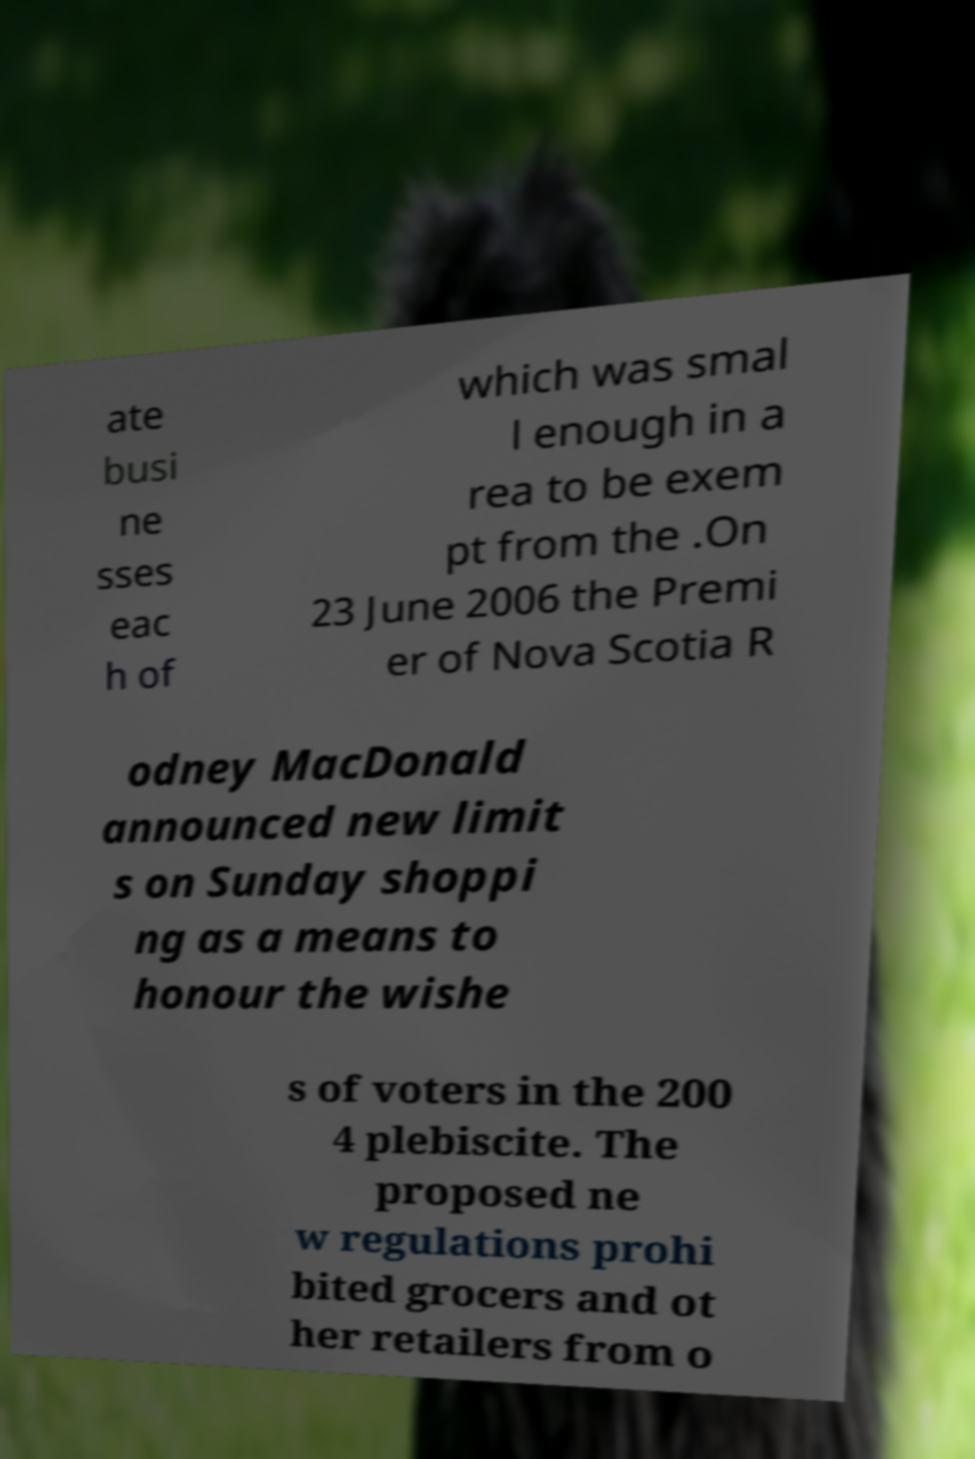Can you read and provide the text displayed in the image?This photo seems to have some interesting text. Can you extract and type it out for me? ate busi ne sses eac h of which was smal l enough in a rea to be exem pt from the .On 23 June 2006 the Premi er of Nova Scotia R odney MacDonald announced new limit s on Sunday shoppi ng as a means to honour the wishe s of voters in the 200 4 plebiscite. The proposed ne w regulations prohi bited grocers and ot her retailers from o 